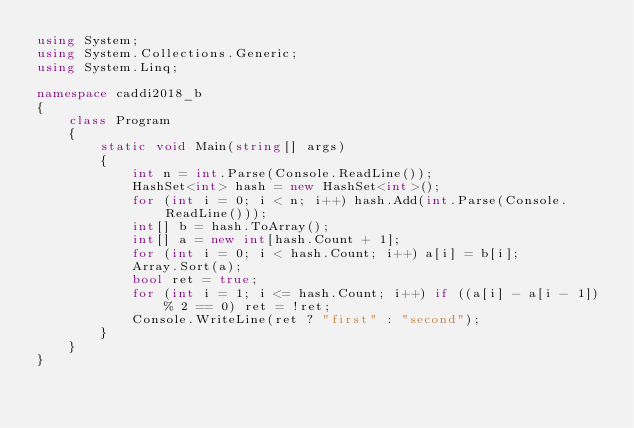Convert code to text. <code><loc_0><loc_0><loc_500><loc_500><_C#_>using System;
using System.Collections.Generic;
using System.Linq;

namespace caddi2018_b
{
    class Program
    {
        static void Main(string[] args)
        {
            int n = int.Parse(Console.ReadLine());
            HashSet<int> hash = new HashSet<int>();
            for (int i = 0; i < n; i++) hash.Add(int.Parse(Console.ReadLine()));
            int[] b = hash.ToArray();
            int[] a = new int[hash.Count + 1];
            for (int i = 0; i < hash.Count; i++) a[i] = b[i];
            Array.Sort(a);
            bool ret = true;
            for (int i = 1; i <= hash.Count; i++) if ((a[i] - a[i - 1]) % 2 == 0) ret = !ret;
            Console.WriteLine(ret ? "first" : "second");
        }
    }
}</code> 